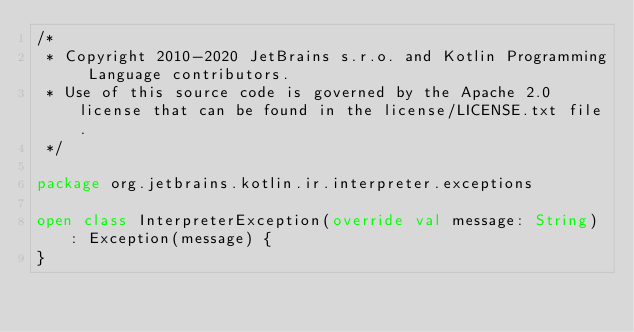<code> <loc_0><loc_0><loc_500><loc_500><_Kotlin_>/*
 * Copyright 2010-2020 JetBrains s.r.o. and Kotlin Programming Language contributors.
 * Use of this source code is governed by the Apache 2.0 license that can be found in the license/LICENSE.txt file.
 */

package org.jetbrains.kotlin.ir.interpreter.exceptions

open class InterpreterException(override val message: String) : Exception(message) {
}</code> 